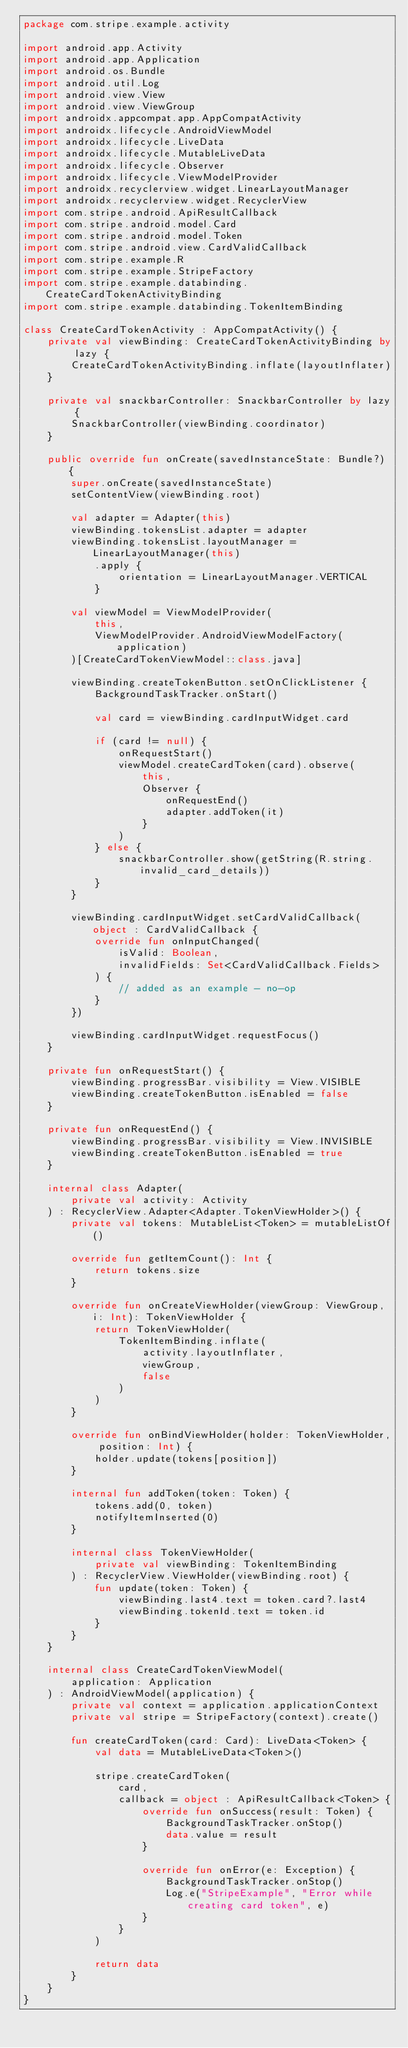Convert code to text. <code><loc_0><loc_0><loc_500><loc_500><_Kotlin_>package com.stripe.example.activity

import android.app.Activity
import android.app.Application
import android.os.Bundle
import android.util.Log
import android.view.View
import android.view.ViewGroup
import androidx.appcompat.app.AppCompatActivity
import androidx.lifecycle.AndroidViewModel
import androidx.lifecycle.LiveData
import androidx.lifecycle.MutableLiveData
import androidx.lifecycle.Observer
import androidx.lifecycle.ViewModelProvider
import androidx.recyclerview.widget.LinearLayoutManager
import androidx.recyclerview.widget.RecyclerView
import com.stripe.android.ApiResultCallback
import com.stripe.android.model.Card
import com.stripe.android.model.Token
import com.stripe.android.view.CardValidCallback
import com.stripe.example.R
import com.stripe.example.StripeFactory
import com.stripe.example.databinding.CreateCardTokenActivityBinding
import com.stripe.example.databinding.TokenItemBinding

class CreateCardTokenActivity : AppCompatActivity() {
    private val viewBinding: CreateCardTokenActivityBinding by lazy {
        CreateCardTokenActivityBinding.inflate(layoutInflater)
    }

    private val snackbarController: SnackbarController by lazy {
        SnackbarController(viewBinding.coordinator)
    }

    public override fun onCreate(savedInstanceState: Bundle?) {
        super.onCreate(savedInstanceState)
        setContentView(viewBinding.root)

        val adapter = Adapter(this)
        viewBinding.tokensList.adapter = adapter
        viewBinding.tokensList.layoutManager = LinearLayoutManager(this)
            .apply {
                orientation = LinearLayoutManager.VERTICAL
            }

        val viewModel = ViewModelProvider(
            this,
            ViewModelProvider.AndroidViewModelFactory(application)
        )[CreateCardTokenViewModel::class.java]

        viewBinding.createTokenButton.setOnClickListener {
            BackgroundTaskTracker.onStart()

            val card = viewBinding.cardInputWidget.card

            if (card != null) {
                onRequestStart()
                viewModel.createCardToken(card).observe(
                    this,
                    Observer {
                        onRequestEnd()
                        adapter.addToken(it)
                    }
                )
            } else {
                snackbarController.show(getString(R.string.invalid_card_details))
            }
        }

        viewBinding.cardInputWidget.setCardValidCallback(object : CardValidCallback {
            override fun onInputChanged(
                isValid: Boolean,
                invalidFields: Set<CardValidCallback.Fields>
            ) {
                // added as an example - no-op
            }
        })

        viewBinding.cardInputWidget.requestFocus()
    }

    private fun onRequestStart() {
        viewBinding.progressBar.visibility = View.VISIBLE
        viewBinding.createTokenButton.isEnabled = false
    }

    private fun onRequestEnd() {
        viewBinding.progressBar.visibility = View.INVISIBLE
        viewBinding.createTokenButton.isEnabled = true
    }

    internal class Adapter(
        private val activity: Activity
    ) : RecyclerView.Adapter<Adapter.TokenViewHolder>() {
        private val tokens: MutableList<Token> = mutableListOf()

        override fun getItemCount(): Int {
            return tokens.size
        }

        override fun onCreateViewHolder(viewGroup: ViewGroup, i: Int): TokenViewHolder {
            return TokenViewHolder(
                TokenItemBinding.inflate(
                    activity.layoutInflater,
                    viewGroup,
                    false
                )
            )
        }

        override fun onBindViewHolder(holder: TokenViewHolder, position: Int) {
            holder.update(tokens[position])
        }

        internal fun addToken(token: Token) {
            tokens.add(0, token)
            notifyItemInserted(0)
        }

        internal class TokenViewHolder(
            private val viewBinding: TokenItemBinding
        ) : RecyclerView.ViewHolder(viewBinding.root) {
            fun update(token: Token) {
                viewBinding.last4.text = token.card?.last4
                viewBinding.tokenId.text = token.id
            }
        }
    }

    internal class CreateCardTokenViewModel(
        application: Application
    ) : AndroidViewModel(application) {
        private val context = application.applicationContext
        private val stripe = StripeFactory(context).create()

        fun createCardToken(card: Card): LiveData<Token> {
            val data = MutableLiveData<Token>()

            stripe.createCardToken(
                card,
                callback = object : ApiResultCallback<Token> {
                    override fun onSuccess(result: Token) {
                        BackgroundTaskTracker.onStop()
                        data.value = result
                    }

                    override fun onError(e: Exception) {
                        BackgroundTaskTracker.onStop()
                        Log.e("StripeExample", "Error while creating card token", e)
                    }
                }
            )

            return data
        }
    }
}
</code> 